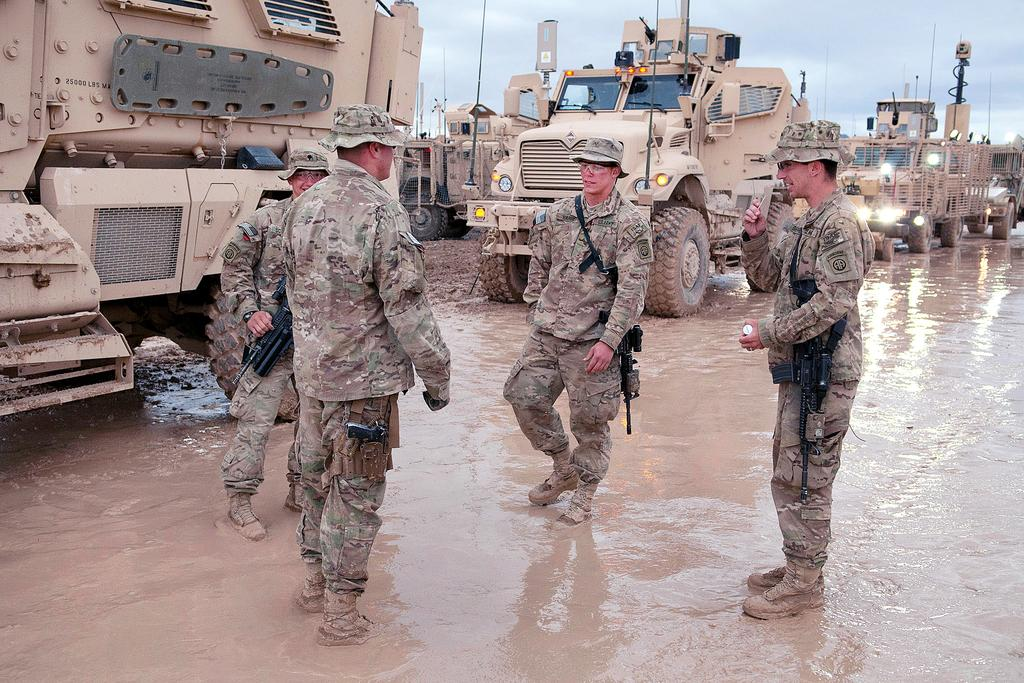What are the people in the image doing? The people in the image are standing on the ground and holding guns. What else can be seen in the image besides the people? There are some objects in the image. What is visible in the background of the image? There are vehicles and the sky visible in the background. How many bikes are being sorted by the people in the image? There are no bikes present in the image, and the people are not sorting anything. 